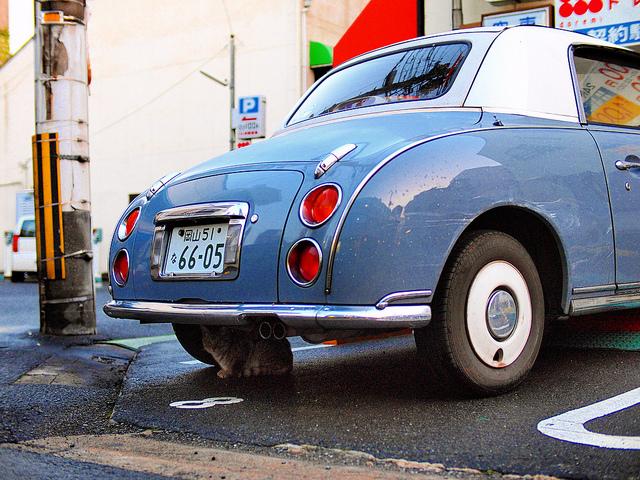What letter is on the blue sign?
Write a very short answer. P. What brand of vehicle is this?
Concise answer only. Unknown. What number is the license plate?
Write a very short answer. 66-05. 